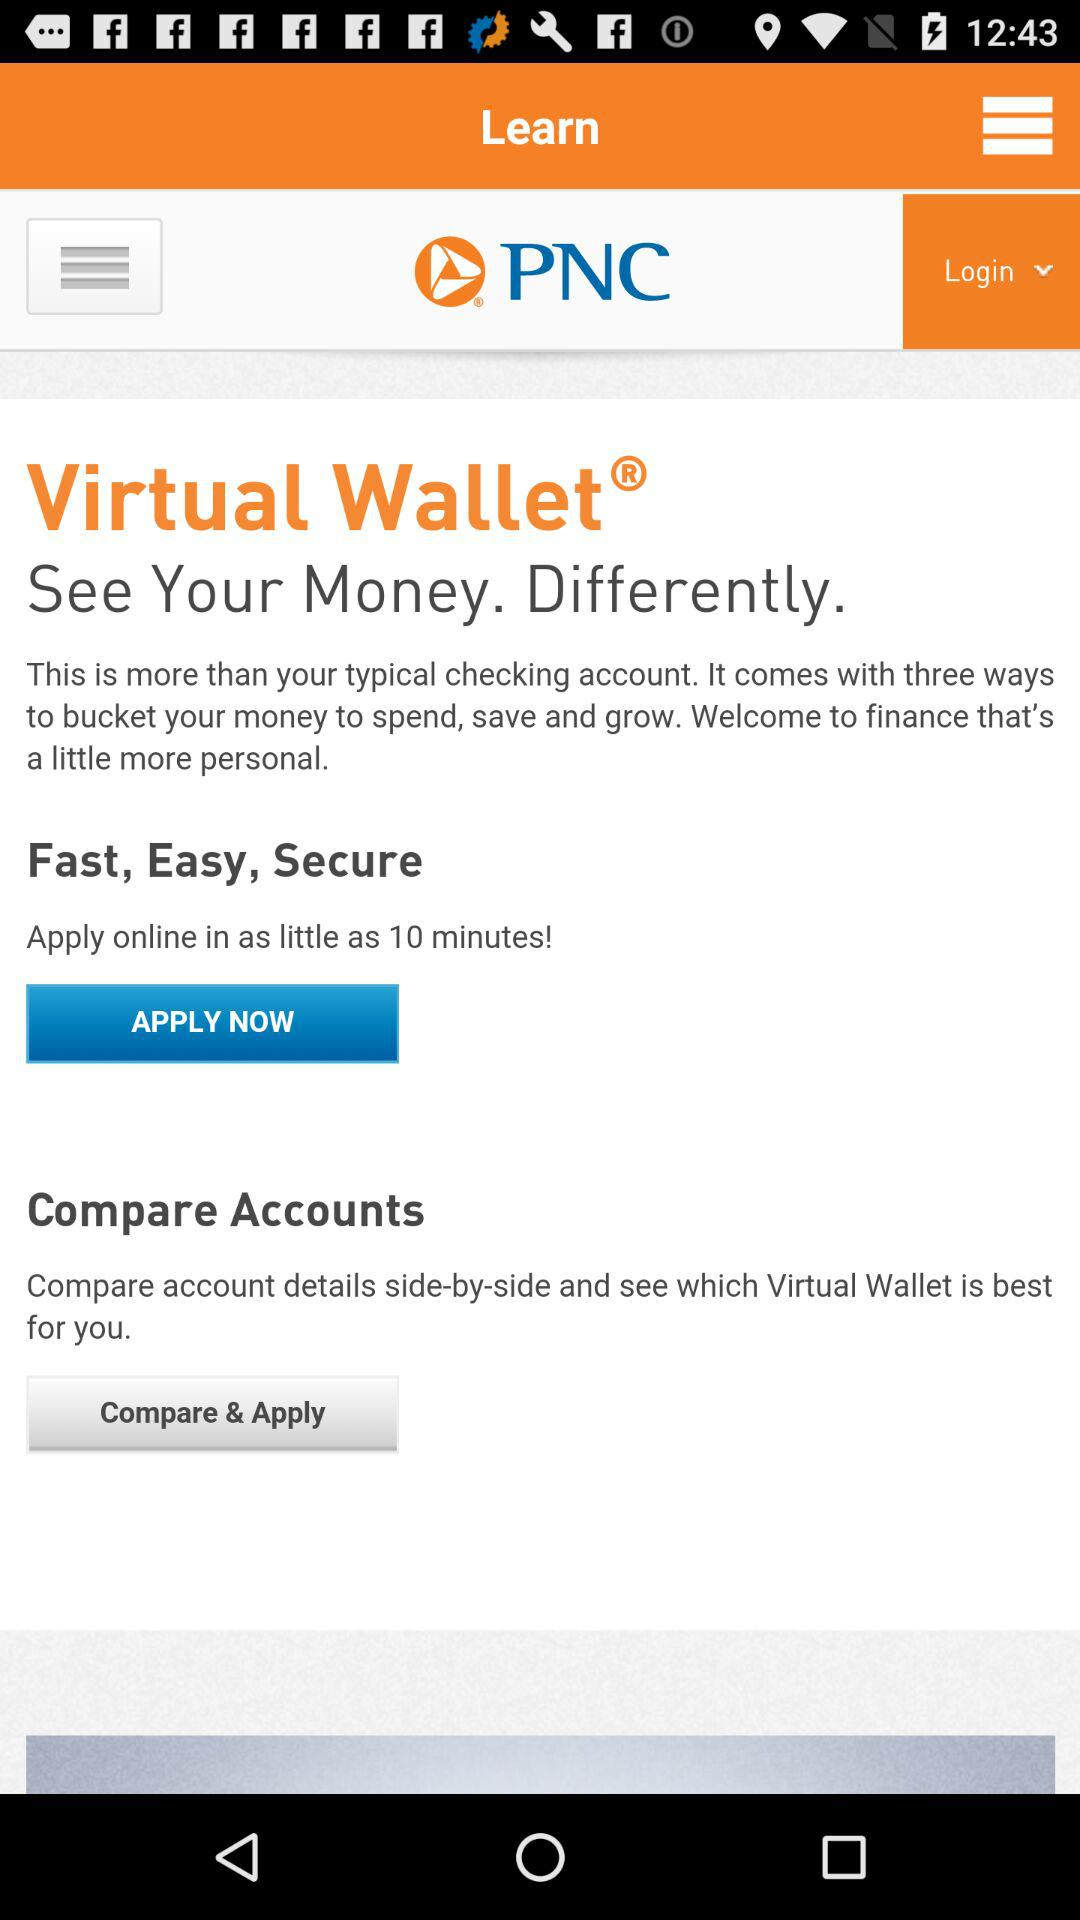What is the name of the application? The name of the application is "PNC". 